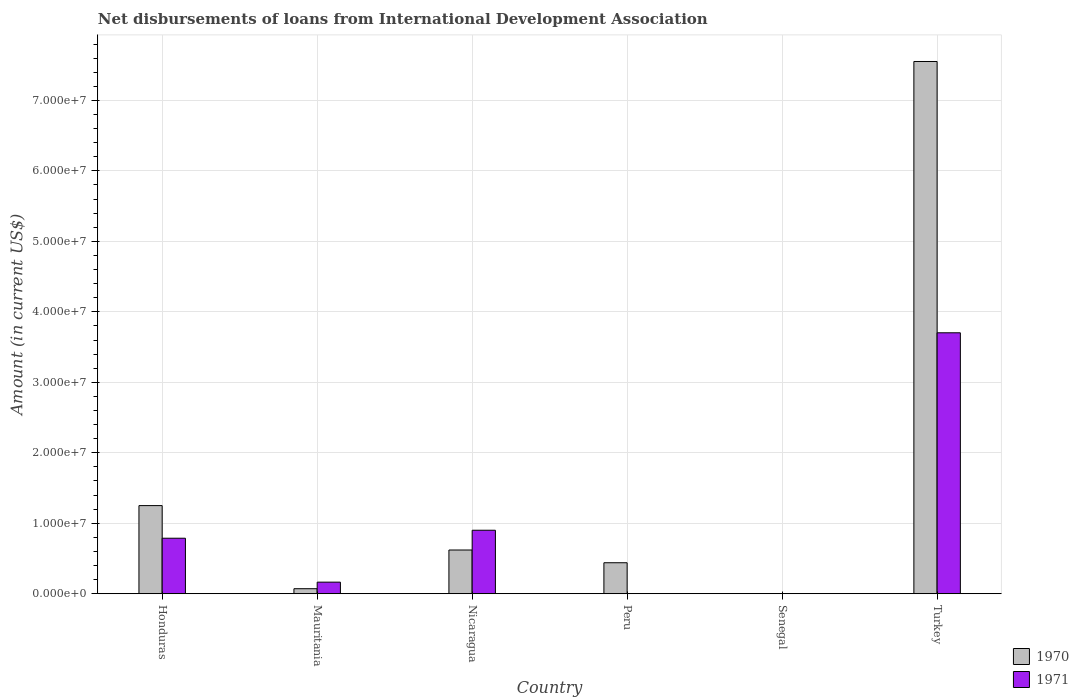Are the number of bars on each tick of the X-axis equal?
Provide a succinct answer. No. How many bars are there on the 2nd tick from the left?
Make the answer very short. 2. What is the label of the 2nd group of bars from the left?
Give a very brief answer. Mauritania. Across all countries, what is the maximum amount of loans disbursed in 1970?
Keep it short and to the point. 7.55e+07. In which country was the amount of loans disbursed in 1970 maximum?
Your answer should be very brief. Turkey. What is the total amount of loans disbursed in 1971 in the graph?
Offer a very short reply. 5.56e+07. What is the difference between the amount of loans disbursed in 1970 in Honduras and that in Peru?
Your answer should be compact. 8.11e+06. What is the difference between the amount of loans disbursed in 1970 in Turkey and the amount of loans disbursed in 1971 in Peru?
Your response must be concise. 7.55e+07. What is the average amount of loans disbursed in 1971 per country?
Offer a very short reply. 9.26e+06. What is the difference between the amount of loans disbursed of/in 1971 and amount of loans disbursed of/in 1970 in Nicaragua?
Provide a succinct answer. 2.80e+06. What is the ratio of the amount of loans disbursed in 1971 in Honduras to that in Mauritania?
Keep it short and to the point. 4.79. Is the difference between the amount of loans disbursed in 1971 in Nicaragua and Turkey greater than the difference between the amount of loans disbursed in 1970 in Nicaragua and Turkey?
Keep it short and to the point. Yes. What is the difference between the highest and the second highest amount of loans disbursed in 1970?
Your answer should be very brief. 6.93e+07. What is the difference between the highest and the lowest amount of loans disbursed in 1970?
Offer a very short reply. 7.55e+07. In how many countries, is the amount of loans disbursed in 1971 greater than the average amount of loans disbursed in 1971 taken over all countries?
Ensure brevity in your answer.  1. Is the sum of the amount of loans disbursed in 1970 in Peru and Turkey greater than the maximum amount of loans disbursed in 1971 across all countries?
Offer a very short reply. Yes. Are all the bars in the graph horizontal?
Ensure brevity in your answer.  No. How many countries are there in the graph?
Offer a very short reply. 6. What is the difference between two consecutive major ticks on the Y-axis?
Keep it short and to the point. 1.00e+07. Are the values on the major ticks of Y-axis written in scientific E-notation?
Offer a very short reply. Yes. Does the graph contain grids?
Offer a very short reply. Yes. How are the legend labels stacked?
Give a very brief answer. Vertical. What is the title of the graph?
Provide a short and direct response. Net disbursements of loans from International Development Association. What is the label or title of the X-axis?
Ensure brevity in your answer.  Country. What is the label or title of the Y-axis?
Provide a succinct answer. Amount (in current US$). What is the Amount (in current US$) in 1970 in Honduras?
Your answer should be compact. 1.25e+07. What is the Amount (in current US$) of 1971 in Honduras?
Offer a very short reply. 7.88e+06. What is the Amount (in current US$) in 1970 in Mauritania?
Your answer should be compact. 7.15e+05. What is the Amount (in current US$) in 1971 in Mauritania?
Your response must be concise. 1.64e+06. What is the Amount (in current US$) of 1970 in Nicaragua?
Make the answer very short. 6.21e+06. What is the Amount (in current US$) of 1971 in Nicaragua?
Keep it short and to the point. 9.01e+06. What is the Amount (in current US$) of 1970 in Peru?
Give a very brief answer. 4.40e+06. What is the Amount (in current US$) in 1970 in Turkey?
Offer a very short reply. 7.55e+07. What is the Amount (in current US$) in 1971 in Turkey?
Your answer should be compact. 3.70e+07. Across all countries, what is the maximum Amount (in current US$) of 1970?
Ensure brevity in your answer.  7.55e+07. Across all countries, what is the maximum Amount (in current US$) of 1971?
Provide a short and direct response. 3.70e+07. Across all countries, what is the minimum Amount (in current US$) of 1970?
Your answer should be very brief. 0. What is the total Amount (in current US$) in 1970 in the graph?
Your answer should be very brief. 9.94e+07. What is the total Amount (in current US$) of 1971 in the graph?
Your answer should be very brief. 5.56e+07. What is the difference between the Amount (in current US$) of 1970 in Honduras and that in Mauritania?
Provide a succinct answer. 1.18e+07. What is the difference between the Amount (in current US$) of 1971 in Honduras and that in Mauritania?
Your answer should be very brief. 6.23e+06. What is the difference between the Amount (in current US$) of 1970 in Honduras and that in Nicaragua?
Offer a very short reply. 6.30e+06. What is the difference between the Amount (in current US$) of 1971 in Honduras and that in Nicaragua?
Keep it short and to the point. -1.13e+06. What is the difference between the Amount (in current US$) of 1970 in Honduras and that in Peru?
Offer a terse response. 8.11e+06. What is the difference between the Amount (in current US$) in 1970 in Honduras and that in Turkey?
Offer a very short reply. -6.30e+07. What is the difference between the Amount (in current US$) in 1971 in Honduras and that in Turkey?
Keep it short and to the point. -2.92e+07. What is the difference between the Amount (in current US$) of 1970 in Mauritania and that in Nicaragua?
Provide a succinct answer. -5.49e+06. What is the difference between the Amount (in current US$) of 1971 in Mauritania and that in Nicaragua?
Offer a terse response. -7.36e+06. What is the difference between the Amount (in current US$) of 1970 in Mauritania and that in Peru?
Your answer should be compact. -3.68e+06. What is the difference between the Amount (in current US$) in 1970 in Mauritania and that in Turkey?
Make the answer very short. -7.48e+07. What is the difference between the Amount (in current US$) of 1971 in Mauritania and that in Turkey?
Offer a terse response. -3.54e+07. What is the difference between the Amount (in current US$) of 1970 in Nicaragua and that in Peru?
Offer a terse response. 1.81e+06. What is the difference between the Amount (in current US$) in 1970 in Nicaragua and that in Turkey?
Make the answer very short. -6.93e+07. What is the difference between the Amount (in current US$) of 1971 in Nicaragua and that in Turkey?
Make the answer very short. -2.80e+07. What is the difference between the Amount (in current US$) in 1970 in Peru and that in Turkey?
Your answer should be compact. -7.11e+07. What is the difference between the Amount (in current US$) of 1970 in Honduras and the Amount (in current US$) of 1971 in Mauritania?
Your answer should be compact. 1.09e+07. What is the difference between the Amount (in current US$) in 1970 in Honduras and the Amount (in current US$) in 1971 in Nicaragua?
Offer a terse response. 3.50e+06. What is the difference between the Amount (in current US$) of 1970 in Honduras and the Amount (in current US$) of 1971 in Turkey?
Keep it short and to the point. -2.45e+07. What is the difference between the Amount (in current US$) of 1970 in Mauritania and the Amount (in current US$) of 1971 in Nicaragua?
Offer a terse response. -8.30e+06. What is the difference between the Amount (in current US$) of 1970 in Mauritania and the Amount (in current US$) of 1971 in Turkey?
Your response must be concise. -3.63e+07. What is the difference between the Amount (in current US$) of 1970 in Nicaragua and the Amount (in current US$) of 1971 in Turkey?
Offer a terse response. -3.08e+07. What is the difference between the Amount (in current US$) of 1970 in Peru and the Amount (in current US$) of 1971 in Turkey?
Keep it short and to the point. -3.26e+07. What is the average Amount (in current US$) in 1970 per country?
Your response must be concise. 1.66e+07. What is the average Amount (in current US$) of 1971 per country?
Your answer should be compact. 9.26e+06. What is the difference between the Amount (in current US$) in 1970 and Amount (in current US$) in 1971 in Honduras?
Your response must be concise. 4.63e+06. What is the difference between the Amount (in current US$) of 1970 and Amount (in current US$) of 1971 in Mauritania?
Keep it short and to the point. -9.30e+05. What is the difference between the Amount (in current US$) in 1970 and Amount (in current US$) in 1971 in Nicaragua?
Your answer should be compact. -2.80e+06. What is the difference between the Amount (in current US$) in 1970 and Amount (in current US$) in 1971 in Turkey?
Give a very brief answer. 3.85e+07. What is the ratio of the Amount (in current US$) of 1970 in Honduras to that in Mauritania?
Your answer should be very brief. 17.49. What is the ratio of the Amount (in current US$) in 1971 in Honduras to that in Mauritania?
Keep it short and to the point. 4.79. What is the ratio of the Amount (in current US$) of 1970 in Honduras to that in Nicaragua?
Give a very brief answer. 2.02. What is the ratio of the Amount (in current US$) of 1971 in Honduras to that in Nicaragua?
Keep it short and to the point. 0.87. What is the ratio of the Amount (in current US$) in 1970 in Honduras to that in Peru?
Your answer should be very brief. 2.84. What is the ratio of the Amount (in current US$) in 1970 in Honduras to that in Turkey?
Your response must be concise. 0.17. What is the ratio of the Amount (in current US$) of 1971 in Honduras to that in Turkey?
Make the answer very short. 0.21. What is the ratio of the Amount (in current US$) in 1970 in Mauritania to that in Nicaragua?
Your response must be concise. 0.12. What is the ratio of the Amount (in current US$) of 1971 in Mauritania to that in Nicaragua?
Ensure brevity in your answer.  0.18. What is the ratio of the Amount (in current US$) in 1970 in Mauritania to that in Peru?
Your response must be concise. 0.16. What is the ratio of the Amount (in current US$) in 1970 in Mauritania to that in Turkey?
Ensure brevity in your answer.  0.01. What is the ratio of the Amount (in current US$) in 1971 in Mauritania to that in Turkey?
Your answer should be very brief. 0.04. What is the ratio of the Amount (in current US$) of 1970 in Nicaragua to that in Peru?
Ensure brevity in your answer.  1.41. What is the ratio of the Amount (in current US$) in 1970 in Nicaragua to that in Turkey?
Make the answer very short. 0.08. What is the ratio of the Amount (in current US$) in 1971 in Nicaragua to that in Turkey?
Your answer should be very brief. 0.24. What is the ratio of the Amount (in current US$) in 1970 in Peru to that in Turkey?
Your answer should be very brief. 0.06. What is the difference between the highest and the second highest Amount (in current US$) in 1970?
Your response must be concise. 6.30e+07. What is the difference between the highest and the second highest Amount (in current US$) of 1971?
Your answer should be very brief. 2.80e+07. What is the difference between the highest and the lowest Amount (in current US$) in 1970?
Offer a terse response. 7.55e+07. What is the difference between the highest and the lowest Amount (in current US$) of 1971?
Provide a short and direct response. 3.70e+07. 